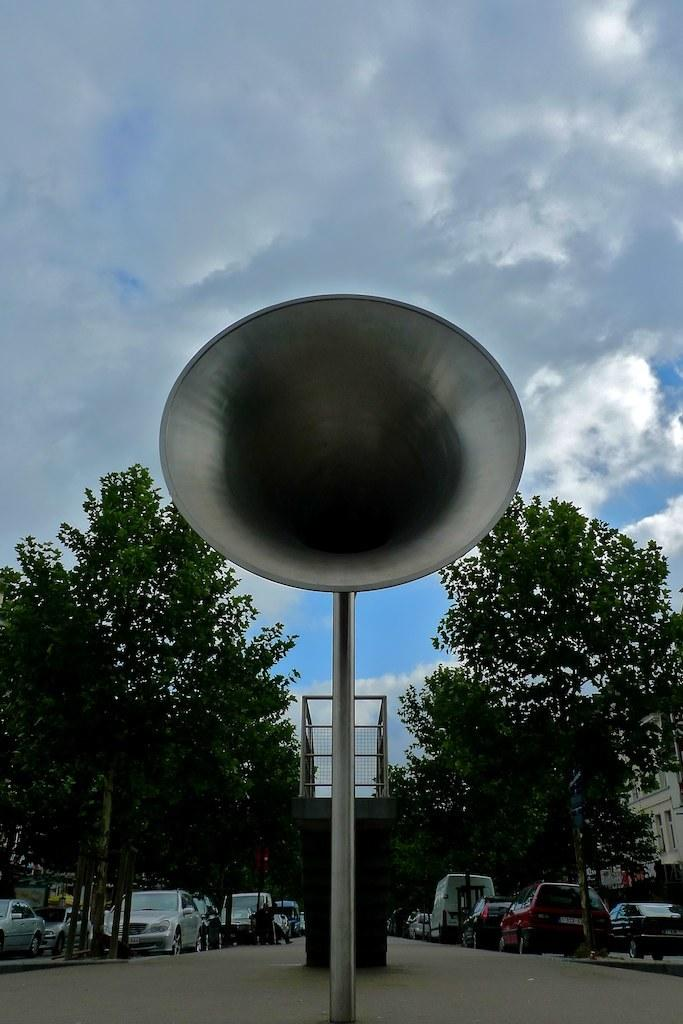What types of objects can be seen in the image? There are vehicles, trees, and a speaker in the image. Are there any living beings present in the image? Yes, there are people in the image. What structure can be seen in the image? There is a building in the image. What is the purpose of the grille in the image? The grille is likely used for ventilation or decoration. What can be seen in the background of the image? The sky is visible in the background of the image. How many snails are crawling on the speaker in the image? There are no snails present in the image; the speaker is not associated with any snails. 